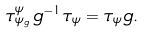Convert formula to latex. <formula><loc_0><loc_0><loc_500><loc_500>\tau _ { \psi _ { g } } ^ { \psi } \, g ^ { - 1 } \tau _ { \psi } = \tau _ { \psi } g .</formula> 